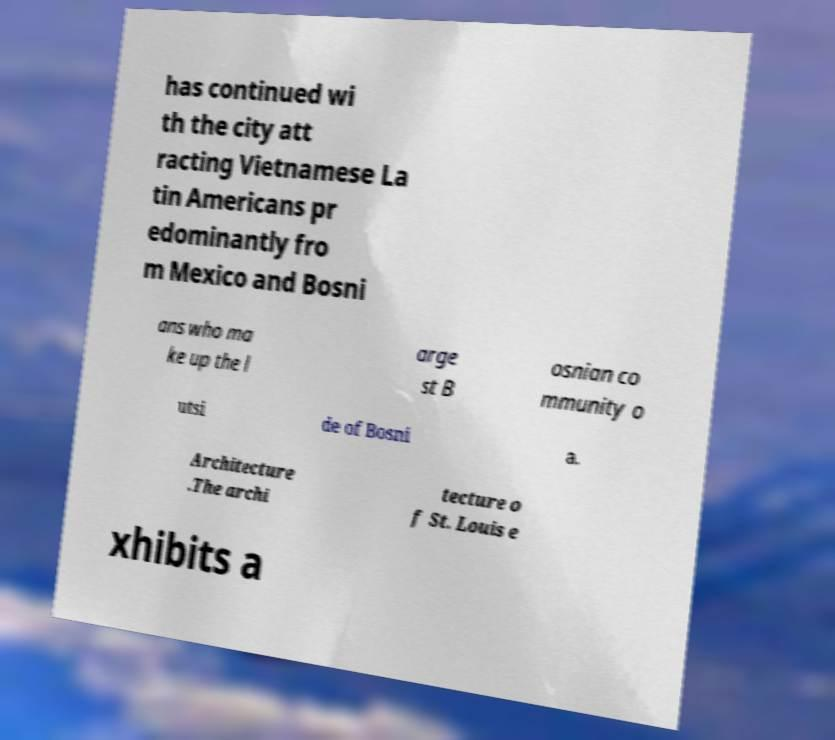What messages or text are displayed in this image? I need them in a readable, typed format. has continued wi th the city att racting Vietnamese La tin Americans pr edominantly fro m Mexico and Bosni ans who ma ke up the l arge st B osnian co mmunity o utsi de of Bosni a. Architecture .The archi tecture o f St. Louis e xhibits a 